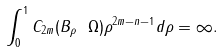<formula> <loc_0><loc_0><loc_500><loc_500>\int _ { 0 } ^ { 1 } C _ { 2 m } ( B _ { \rho } \ \Omega ) \rho ^ { 2 m - n - 1 } d \rho = \infty .</formula> 